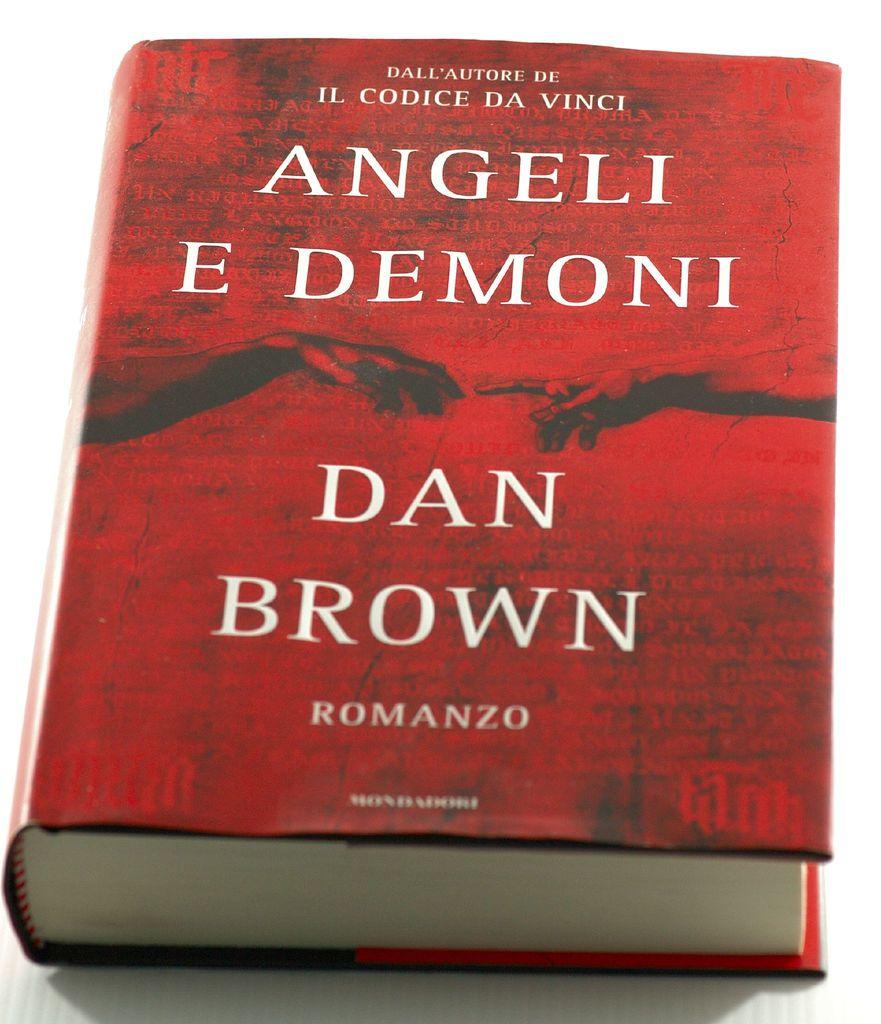What is the author's name from the cover of the book?
Make the answer very short. Dan brown. What is the title of the book?
Your response must be concise. Angeli e demoni. 